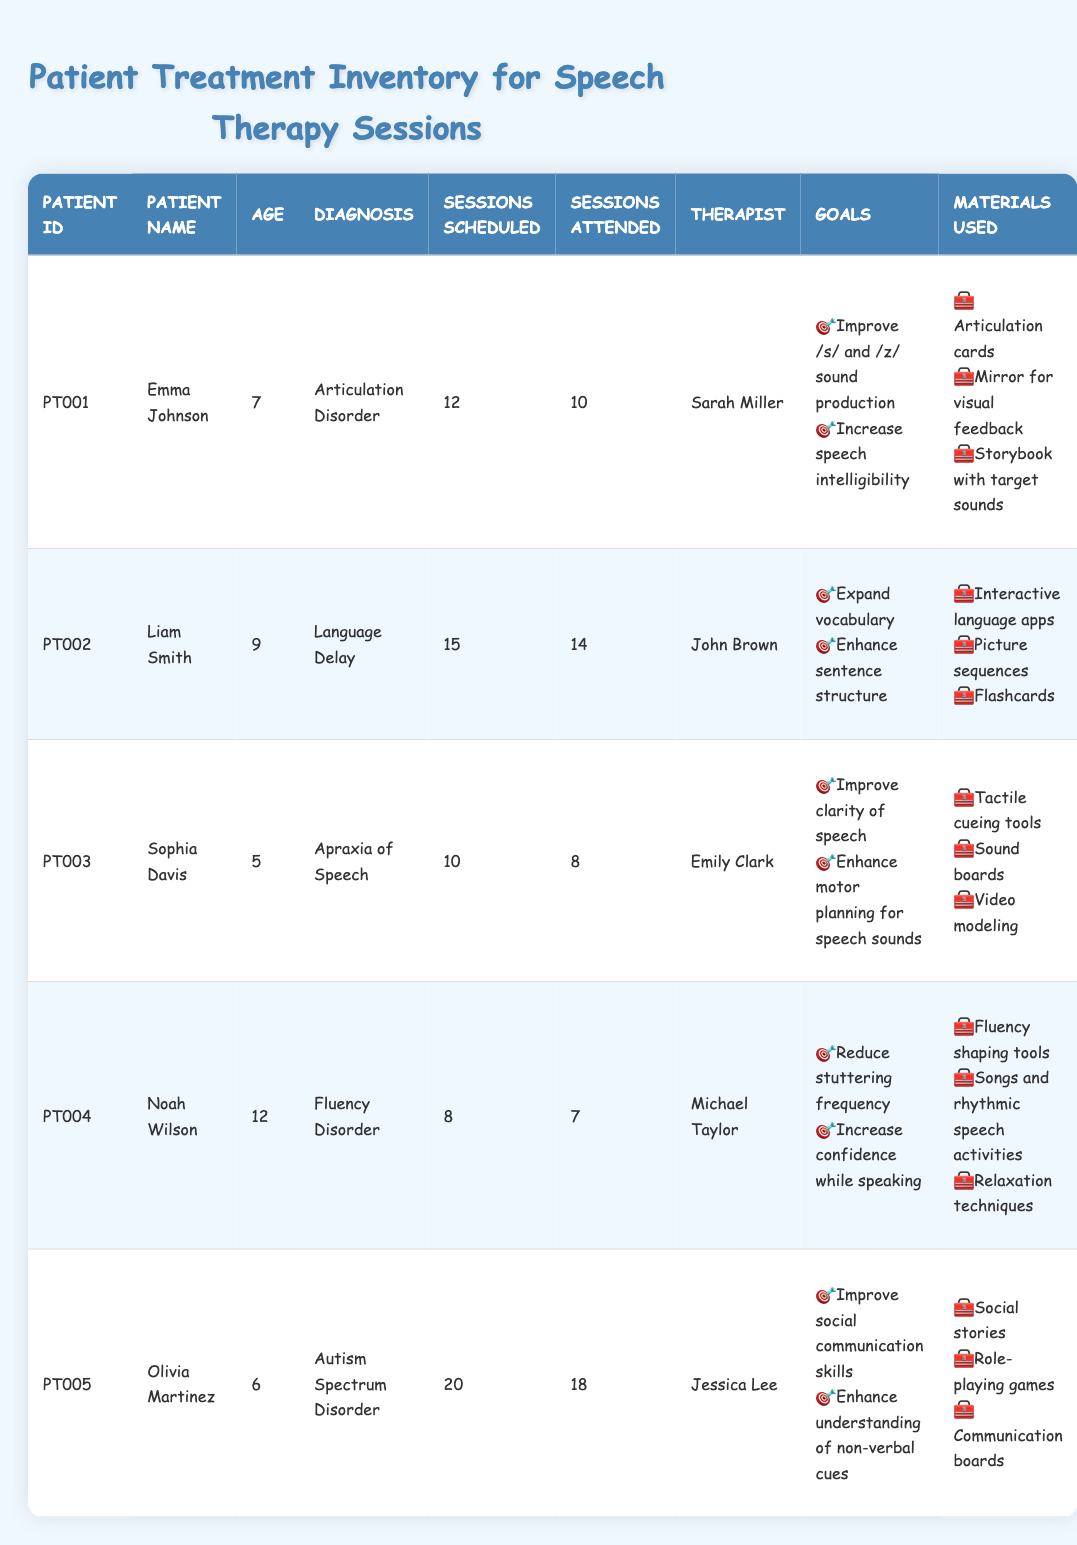What is the diagnosis of Emma Johnson? Emma Johnson is listed under the "Diagnosis" column in the table, where her diagnosis is specified as "Articulation Disorder."
Answer: Articulation Disorder How many sessions did Liam Smith attend? According to the "Sessions Attended" column, Liam Smith attended 14 out of the 15 scheduled sessions.
Answer: 14 Which therapist is associated with Sophia Davis? The "Therapist" column in the table indicates that Sophia Davis is receiving treatment from Emily Clark.
Answer: Emily Clark What is the average age of the patients listed in the table? To find the average age, sum all ages: (7 + 9 + 5 + 12 + 6) = 39. There are 5 patients, so the average age is 39 / 5 = 7.8.
Answer: 7.8 Did Noah Wilson attend all scheduled sessions? In the "Sessions Attended" column for Noah Wilson, it shows that he attended 7 out of 8 scheduled sessions, which means he did not attend all sessions.
Answer: No Which patient has the most sessions scheduled? By examining the "Sessions Scheduled" column, Olivia Martinez has 20 sessions scheduled, which is more than any other patient.
Answer: Olivia Martinez Are any materials used for therapy by both Emma Johnson and Liam Smith? Looking at the "Materials Used" for both patients, Emma Johnson uses articulation cards and a mirror, while Liam Smith uses interactive language apps and flashcards. There are no common materials used by both.
Answer: No What is the difference in the number of sessions scheduled between Olivia Martinez and Noah Wilson? Olivia Martinez has 20 sessions scheduled while Noah Wilson has 8 sessions. The difference is calculated as 20 - 8 = 12.
Answer: 12 How many goals are set for the patient with a diagnosis of Apraxia of Speech? Sophia Davis has two goals listed for her treatment. Counting the items in the "Goals" section for her, we see: 1. Improve clarity of speech and 2. Enhance motor planning for speech sounds.
Answer: 2 